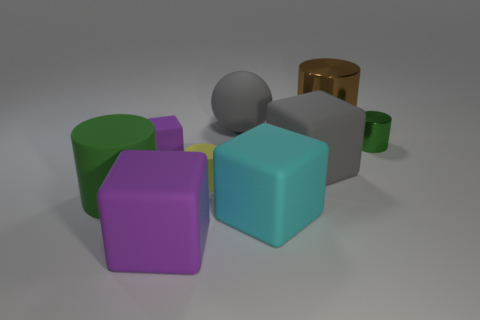How many objects are small shiny things or things that are on the right side of the brown thing?
Offer a very short reply. 1. The cylinder that is on the right side of the large green cylinder and to the left of the gray matte block is made of what material?
Make the answer very short. Rubber. There is a green thing that is in front of the small green cylinder; what is it made of?
Provide a succinct answer. Rubber. There is a large cylinder that is made of the same material as the sphere; what color is it?
Your answer should be compact. Green. Does the large brown object have the same shape as the thing that is right of the big brown object?
Offer a very short reply. Yes. Are there any big brown things left of the big gray ball?
Ensure brevity in your answer.  No. There is a block that is the same color as the big ball; what is it made of?
Ensure brevity in your answer.  Rubber. There is a yellow thing; does it have the same size as the brown thing on the right side of the tiny purple matte cube?
Your answer should be compact. No. Is there another tiny ball of the same color as the sphere?
Make the answer very short. No. Is there a big cyan matte thing of the same shape as the large green matte object?
Your answer should be very brief. No. 